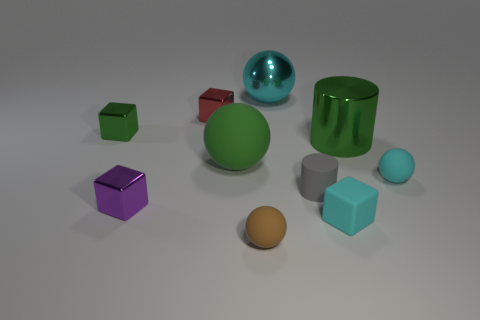Subtract all blocks. How many objects are left? 6 Add 7 rubber balls. How many rubber balls are left? 10 Add 8 small cyan metal cylinders. How many small cyan metal cylinders exist? 8 Subtract 0 brown blocks. How many objects are left? 10 Subtract all purple things. Subtract all small purple blocks. How many objects are left? 8 